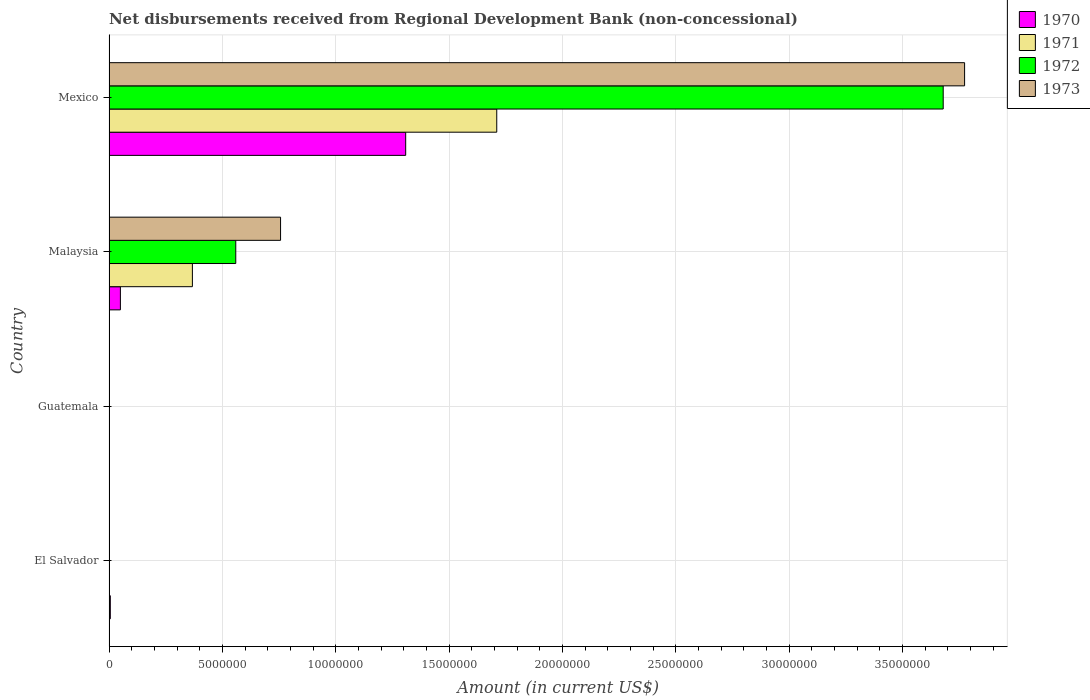What is the label of the 2nd group of bars from the top?
Offer a very short reply. Malaysia. In how many cases, is the number of bars for a given country not equal to the number of legend labels?
Offer a terse response. 2. What is the amount of disbursements received from Regional Development Bank in 1973 in El Salvador?
Provide a succinct answer. 0. Across all countries, what is the maximum amount of disbursements received from Regional Development Bank in 1973?
Your answer should be very brief. 3.77e+07. Across all countries, what is the minimum amount of disbursements received from Regional Development Bank in 1973?
Your answer should be compact. 0. In which country was the amount of disbursements received from Regional Development Bank in 1971 maximum?
Your response must be concise. Mexico. What is the total amount of disbursements received from Regional Development Bank in 1970 in the graph?
Your answer should be very brief. 1.36e+07. What is the difference between the amount of disbursements received from Regional Development Bank in 1970 in Malaysia and that in Mexico?
Provide a short and direct response. -1.26e+07. What is the difference between the amount of disbursements received from Regional Development Bank in 1971 in Guatemala and the amount of disbursements received from Regional Development Bank in 1970 in Malaysia?
Make the answer very short. -5.02e+05. What is the average amount of disbursements received from Regional Development Bank in 1971 per country?
Offer a terse response. 5.19e+06. What is the difference between the amount of disbursements received from Regional Development Bank in 1971 and amount of disbursements received from Regional Development Bank in 1973 in Mexico?
Provide a succinct answer. -2.06e+07. What is the ratio of the amount of disbursements received from Regional Development Bank in 1970 in El Salvador to that in Malaysia?
Provide a succinct answer. 0.11. Is the amount of disbursements received from Regional Development Bank in 1970 in El Salvador less than that in Mexico?
Offer a very short reply. Yes. Is the difference between the amount of disbursements received from Regional Development Bank in 1971 in Malaysia and Mexico greater than the difference between the amount of disbursements received from Regional Development Bank in 1973 in Malaysia and Mexico?
Ensure brevity in your answer.  Yes. What is the difference between the highest and the second highest amount of disbursements received from Regional Development Bank in 1970?
Provide a short and direct response. 1.26e+07. What is the difference between the highest and the lowest amount of disbursements received from Regional Development Bank in 1973?
Your answer should be very brief. 3.77e+07. Are all the bars in the graph horizontal?
Provide a short and direct response. Yes. What is the difference between two consecutive major ticks on the X-axis?
Provide a short and direct response. 5.00e+06. Are the values on the major ticks of X-axis written in scientific E-notation?
Your answer should be compact. No. Does the graph contain any zero values?
Make the answer very short. Yes. Does the graph contain grids?
Your answer should be compact. Yes. Where does the legend appear in the graph?
Your response must be concise. Top right. How many legend labels are there?
Keep it short and to the point. 4. What is the title of the graph?
Ensure brevity in your answer.  Net disbursements received from Regional Development Bank (non-concessional). Does "1985" appear as one of the legend labels in the graph?
Provide a short and direct response. No. What is the label or title of the Y-axis?
Your answer should be compact. Country. What is the Amount (in current US$) of 1970 in El Salvador?
Provide a succinct answer. 5.70e+04. What is the Amount (in current US$) of 1971 in El Salvador?
Provide a short and direct response. 0. What is the Amount (in current US$) of 1972 in El Salvador?
Ensure brevity in your answer.  0. What is the Amount (in current US$) in 1973 in El Salvador?
Keep it short and to the point. 0. What is the Amount (in current US$) of 1970 in Malaysia?
Offer a terse response. 5.02e+05. What is the Amount (in current US$) of 1971 in Malaysia?
Keep it short and to the point. 3.68e+06. What is the Amount (in current US$) in 1972 in Malaysia?
Offer a very short reply. 5.59e+06. What is the Amount (in current US$) in 1973 in Malaysia?
Your answer should be compact. 7.57e+06. What is the Amount (in current US$) in 1970 in Mexico?
Your response must be concise. 1.31e+07. What is the Amount (in current US$) in 1971 in Mexico?
Offer a terse response. 1.71e+07. What is the Amount (in current US$) in 1972 in Mexico?
Offer a very short reply. 3.68e+07. What is the Amount (in current US$) of 1973 in Mexico?
Provide a succinct answer. 3.77e+07. Across all countries, what is the maximum Amount (in current US$) in 1970?
Your response must be concise. 1.31e+07. Across all countries, what is the maximum Amount (in current US$) of 1971?
Give a very brief answer. 1.71e+07. Across all countries, what is the maximum Amount (in current US$) in 1972?
Offer a very short reply. 3.68e+07. Across all countries, what is the maximum Amount (in current US$) of 1973?
Offer a very short reply. 3.77e+07. Across all countries, what is the minimum Amount (in current US$) of 1971?
Ensure brevity in your answer.  0. Across all countries, what is the minimum Amount (in current US$) of 1972?
Keep it short and to the point. 0. Across all countries, what is the minimum Amount (in current US$) in 1973?
Provide a short and direct response. 0. What is the total Amount (in current US$) in 1970 in the graph?
Offer a terse response. 1.36e+07. What is the total Amount (in current US$) of 1971 in the graph?
Ensure brevity in your answer.  2.08e+07. What is the total Amount (in current US$) in 1972 in the graph?
Make the answer very short. 4.24e+07. What is the total Amount (in current US$) of 1973 in the graph?
Your response must be concise. 4.53e+07. What is the difference between the Amount (in current US$) of 1970 in El Salvador and that in Malaysia?
Provide a succinct answer. -4.45e+05. What is the difference between the Amount (in current US$) in 1970 in El Salvador and that in Mexico?
Offer a very short reply. -1.30e+07. What is the difference between the Amount (in current US$) of 1970 in Malaysia and that in Mexico?
Your response must be concise. -1.26e+07. What is the difference between the Amount (in current US$) in 1971 in Malaysia and that in Mexico?
Ensure brevity in your answer.  -1.34e+07. What is the difference between the Amount (in current US$) of 1972 in Malaysia and that in Mexico?
Make the answer very short. -3.12e+07. What is the difference between the Amount (in current US$) of 1973 in Malaysia and that in Mexico?
Your answer should be compact. -3.02e+07. What is the difference between the Amount (in current US$) of 1970 in El Salvador and the Amount (in current US$) of 1971 in Malaysia?
Provide a short and direct response. -3.62e+06. What is the difference between the Amount (in current US$) of 1970 in El Salvador and the Amount (in current US$) of 1972 in Malaysia?
Give a very brief answer. -5.53e+06. What is the difference between the Amount (in current US$) in 1970 in El Salvador and the Amount (in current US$) in 1973 in Malaysia?
Your answer should be very brief. -7.51e+06. What is the difference between the Amount (in current US$) in 1970 in El Salvador and the Amount (in current US$) in 1971 in Mexico?
Your response must be concise. -1.70e+07. What is the difference between the Amount (in current US$) of 1970 in El Salvador and the Amount (in current US$) of 1972 in Mexico?
Your answer should be compact. -3.67e+07. What is the difference between the Amount (in current US$) of 1970 in El Salvador and the Amount (in current US$) of 1973 in Mexico?
Your answer should be compact. -3.77e+07. What is the difference between the Amount (in current US$) of 1970 in Malaysia and the Amount (in current US$) of 1971 in Mexico?
Ensure brevity in your answer.  -1.66e+07. What is the difference between the Amount (in current US$) in 1970 in Malaysia and the Amount (in current US$) in 1972 in Mexico?
Your answer should be compact. -3.63e+07. What is the difference between the Amount (in current US$) of 1970 in Malaysia and the Amount (in current US$) of 1973 in Mexico?
Provide a succinct answer. -3.72e+07. What is the difference between the Amount (in current US$) in 1971 in Malaysia and the Amount (in current US$) in 1972 in Mexico?
Offer a terse response. -3.31e+07. What is the difference between the Amount (in current US$) of 1971 in Malaysia and the Amount (in current US$) of 1973 in Mexico?
Your answer should be very brief. -3.41e+07. What is the difference between the Amount (in current US$) in 1972 in Malaysia and the Amount (in current US$) in 1973 in Mexico?
Give a very brief answer. -3.21e+07. What is the average Amount (in current US$) of 1970 per country?
Make the answer very short. 3.41e+06. What is the average Amount (in current US$) in 1971 per country?
Give a very brief answer. 5.19e+06. What is the average Amount (in current US$) of 1972 per country?
Make the answer very short. 1.06e+07. What is the average Amount (in current US$) in 1973 per country?
Make the answer very short. 1.13e+07. What is the difference between the Amount (in current US$) in 1970 and Amount (in current US$) in 1971 in Malaysia?
Make the answer very short. -3.18e+06. What is the difference between the Amount (in current US$) of 1970 and Amount (in current US$) of 1972 in Malaysia?
Ensure brevity in your answer.  -5.09e+06. What is the difference between the Amount (in current US$) in 1970 and Amount (in current US$) in 1973 in Malaysia?
Your response must be concise. -7.06e+06. What is the difference between the Amount (in current US$) of 1971 and Amount (in current US$) of 1972 in Malaysia?
Your answer should be very brief. -1.91e+06. What is the difference between the Amount (in current US$) of 1971 and Amount (in current US$) of 1973 in Malaysia?
Your response must be concise. -3.89e+06. What is the difference between the Amount (in current US$) of 1972 and Amount (in current US$) of 1973 in Malaysia?
Offer a very short reply. -1.98e+06. What is the difference between the Amount (in current US$) of 1970 and Amount (in current US$) of 1971 in Mexico?
Keep it short and to the point. -4.02e+06. What is the difference between the Amount (in current US$) in 1970 and Amount (in current US$) in 1972 in Mexico?
Your response must be concise. -2.37e+07. What is the difference between the Amount (in current US$) in 1970 and Amount (in current US$) in 1973 in Mexico?
Your response must be concise. -2.46e+07. What is the difference between the Amount (in current US$) in 1971 and Amount (in current US$) in 1972 in Mexico?
Offer a very short reply. -1.97e+07. What is the difference between the Amount (in current US$) in 1971 and Amount (in current US$) in 1973 in Mexico?
Give a very brief answer. -2.06e+07. What is the difference between the Amount (in current US$) in 1972 and Amount (in current US$) in 1973 in Mexico?
Your response must be concise. -9.43e+05. What is the ratio of the Amount (in current US$) of 1970 in El Salvador to that in Malaysia?
Your answer should be very brief. 0.11. What is the ratio of the Amount (in current US$) of 1970 in El Salvador to that in Mexico?
Your answer should be compact. 0. What is the ratio of the Amount (in current US$) of 1970 in Malaysia to that in Mexico?
Ensure brevity in your answer.  0.04. What is the ratio of the Amount (in current US$) in 1971 in Malaysia to that in Mexico?
Your answer should be compact. 0.21. What is the ratio of the Amount (in current US$) of 1972 in Malaysia to that in Mexico?
Provide a short and direct response. 0.15. What is the ratio of the Amount (in current US$) in 1973 in Malaysia to that in Mexico?
Your response must be concise. 0.2. What is the difference between the highest and the second highest Amount (in current US$) in 1970?
Your answer should be very brief. 1.26e+07. What is the difference between the highest and the lowest Amount (in current US$) in 1970?
Your answer should be compact. 1.31e+07. What is the difference between the highest and the lowest Amount (in current US$) of 1971?
Make the answer very short. 1.71e+07. What is the difference between the highest and the lowest Amount (in current US$) in 1972?
Your response must be concise. 3.68e+07. What is the difference between the highest and the lowest Amount (in current US$) of 1973?
Give a very brief answer. 3.77e+07. 